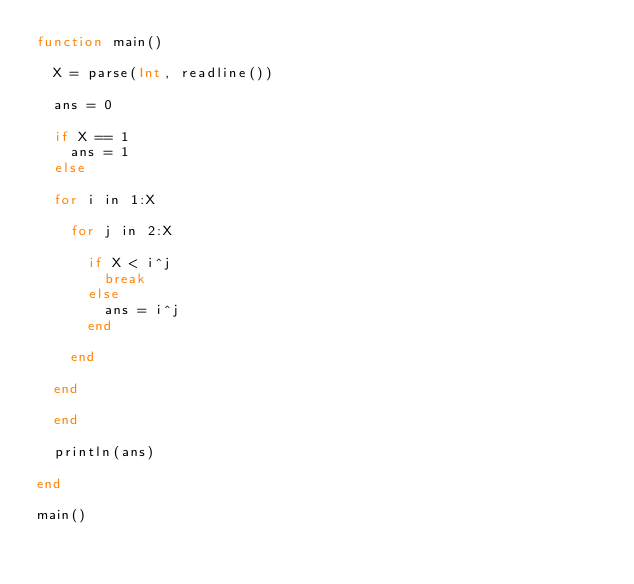<code> <loc_0><loc_0><loc_500><loc_500><_Julia_>function main()
  
  X = parse(Int, readline())
  
  ans = 0

  if X == 1
    ans = 1
  else
  
  for i in 1:X
    
    for j in 2:X
    
    	if X < i^j
      	break
    	else
      	ans = i^j
    	end
      
    end
    
  end
    
  end
  
  println(ans)
  
end

main()</code> 